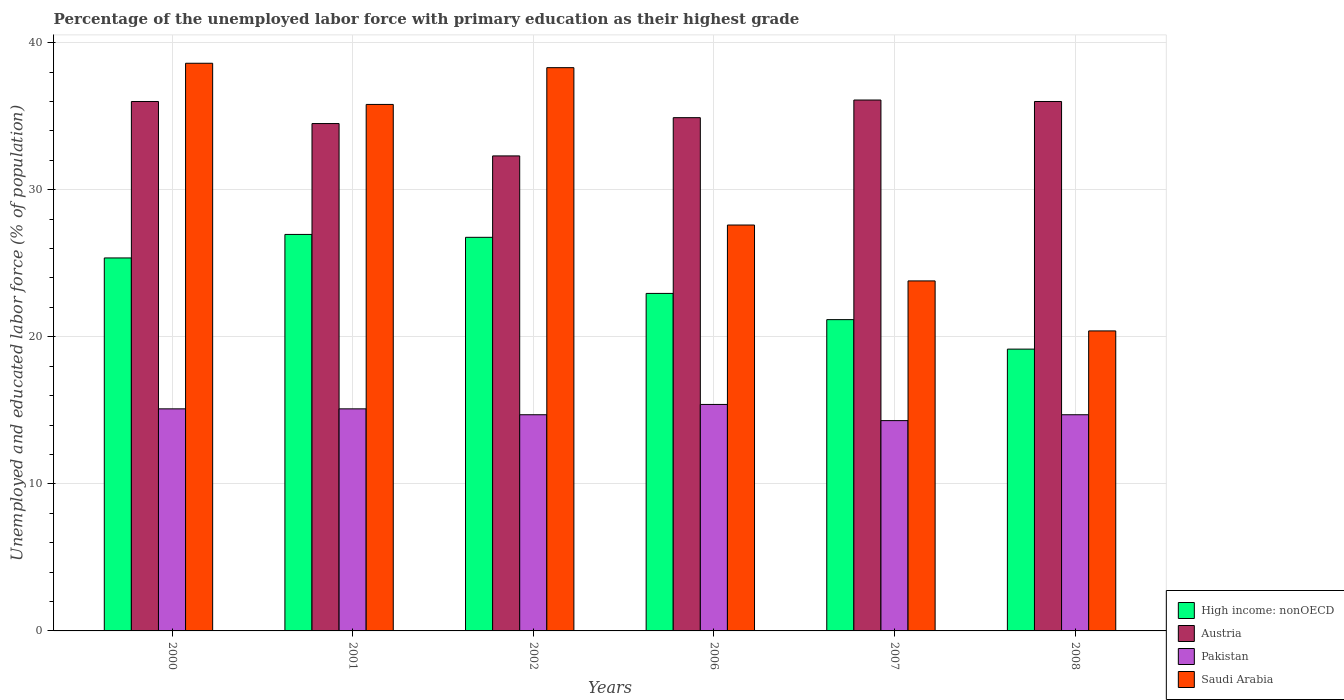How many different coloured bars are there?
Your answer should be very brief. 4. Are the number of bars per tick equal to the number of legend labels?
Provide a short and direct response. Yes. How many bars are there on the 1st tick from the left?
Your answer should be compact. 4. In how many cases, is the number of bars for a given year not equal to the number of legend labels?
Your answer should be compact. 0. What is the percentage of the unemployed labor force with primary education in Pakistan in 2008?
Offer a very short reply. 14.7. Across all years, what is the maximum percentage of the unemployed labor force with primary education in High income: nonOECD?
Provide a succinct answer. 26.96. Across all years, what is the minimum percentage of the unemployed labor force with primary education in Saudi Arabia?
Your response must be concise. 20.4. What is the total percentage of the unemployed labor force with primary education in High income: nonOECD in the graph?
Keep it short and to the point. 142.37. What is the difference between the percentage of the unemployed labor force with primary education in Austria in 2000 and that in 2007?
Make the answer very short. -0.1. What is the difference between the percentage of the unemployed labor force with primary education in Saudi Arabia in 2008 and the percentage of the unemployed labor force with primary education in Austria in 2006?
Make the answer very short. -14.5. What is the average percentage of the unemployed labor force with primary education in Pakistan per year?
Make the answer very short. 14.88. In the year 2002, what is the difference between the percentage of the unemployed labor force with primary education in Austria and percentage of the unemployed labor force with primary education in Pakistan?
Your answer should be compact. 17.6. What is the ratio of the percentage of the unemployed labor force with primary education in Austria in 2002 to that in 2008?
Your answer should be compact. 0.9. Is the difference between the percentage of the unemployed labor force with primary education in Austria in 2000 and 2002 greater than the difference between the percentage of the unemployed labor force with primary education in Pakistan in 2000 and 2002?
Offer a very short reply. Yes. What is the difference between the highest and the second highest percentage of the unemployed labor force with primary education in High income: nonOECD?
Your answer should be very brief. 0.2. What is the difference between the highest and the lowest percentage of the unemployed labor force with primary education in Pakistan?
Give a very brief answer. 1.1. In how many years, is the percentage of the unemployed labor force with primary education in Austria greater than the average percentage of the unemployed labor force with primary education in Austria taken over all years?
Keep it short and to the point. 3. Is the sum of the percentage of the unemployed labor force with primary education in Austria in 2001 and 2002 greater than the maximum percentage of the unemployed labor force with primary education in High income: nonOECD across all years?
Give a very brief answer. Yes. What does the 4th bar from the right in 2008 represents?
Give a very brief answer. High income: nonOECD. Is it the case that in every year, the sum of the percentage of the unemployed labor force with primary education in Saudi Arabia and percentage of the unemployed labor force with primary education in Pakistan is greater than the percentage of the unemployed labor force with primary education in Austria?
Give a very brief answer. No. Are all the bars in the graph horizontal?
Provide a succinct answer. No. How many years are there in the graph?
Your answer should be very brief. 6. Does the graph contain any zero values?
Provide a short and direct response. No. How many legend labels are there?
Provide a short and direct response. 4. What is the title of the graph?
Provide a short and direct response. Percentage of the unemployed labor force with primary education as their highest grade. What is the label or title of the Y-axis?
Give a very brief answer. Unemployed and educated labor force (% of population). What is the Unemployed and educated labor force (% of population) in High income: nonOECD in 2000?
Your response must be concise. 25.36. What is the Unemployed and educated labor force (% of population) of Pakistan in 2000?
Your answer should be compact. 15.1. What is the Unemployed and educated labor force (% of population) in Saudi Arabia in 2000?
Your answer should be very brief. 38.6. What is the Unemployed and educated labor force (% of population) in High income: nonOECD in 2001?
Keep it short and to the point. 26.96. What is the Unemployed and educated labor force (% of population) in Austria in 2001?
Your answer should be compact. 34.5. What is the Unemployed and educated labor force (% of population) of Pakistan in 2001?
Make the answer very short. 15.1. What is the Unemployed and educated labor force (% of population) in Saudi Arabia in 2001?
Offer a terse response. 35.8. What is the Unemployed and educated labor force (% of population) of High income: nonOECD in 2002?
Ensure brevity in your answer.  26.76. What is the Unemployed and educated labor force (% of population) of Austria in 2002?
Ensure brevity in your answer.  32.3. What is the Unemployed and educated labor force (% of population) of Pakistan in 2002?
Your answer should be compact. 14.7. What is the Unemployed and educated labor force (% of population) in Saudi Arabia in 2002?
Give a very brief answer. 38.3. What is the Unemployed and educated labor force (% of population) in High income: nonOECD in 2006?
Give a very brief answer. 22.95. What is the Unemployed and educated labor force (% of population) of Austria in 2006?
Ensure brevity in your answer.  34.9. What is the Unemployed and educated labor force (% of population) in Pakistan in 2006?
Offer a terse response. 15.4. What is the Unemployed and educated labor force (% of population) in Saudi Arabia in 2006?
Your response must be concise. 27.6. What is the Unemployed and educated labor force (% of population) of High income: nonOECD in 2007?
Your response must be concise. 21.17. What is the Unemployed and educated labor force (% of population) in Austria in 2007?
Ensure brevity in your answer.  36.1. What is the Unemployed and educated labor force (% of population) of Pakistan in 2007?
Keep it short and to the point. 14.3. What is the Unemployed and educated labor force (% of population) of Saudi Arabia in 2007?
Give a very brief answer. 23.8. What is the Unemployed and educated labor force (% of population) in High income: nonOECD in 2008?
Your answer should be very brief. 19.16. What is the Unemployed and educated labor force (% of population) in Pakistan in 2008?
Offer a very short reply. 14.7. What is the Unemployed and educated labor force (% of population) in Saudi Arabia in 2008?
Your response must be concise. 20.4. Across all years, what is the maximum Unemployed and educated labor force (% of population) of High income: nonOECD?
Keep it short and to the point. 26.96. Across all years, what is the maximum Unemployed and educated labor force (% of population) of Austria?
Make the answer very short. 36.1. Across all years, what is the maximum Unemployed and educated labor force (% of population) in Pakistan?
Provide a short and direct response. 15.4. Across all years, what is the maximum Unemployed and educated labor force (% of population) of Saudi Arabia?
Provide a succinct answer. 38.6. Across all years, what is the minimum Unemployed and educated labor force (% of population) of High income: nonOECD?
Keep it short and to the point. 19.16. Across all years, what is the minimum Unemployed and educated labor force (% of population) of Austria?
Offer a terse response. 32.3. Across all years, what is the minimum Unemployed and educated labor force (% of population) of Pakistan?
Give a very brief answer. 14.3. Across all years, what is the minimum Unemployed and educated labor force (% of population) of Saudi Arabia?
Offer a very short reply. 20.4. What is the total Unemployed and educated labor force (% of population) in High income: nonOECD in the graph?
Give a very brief answer. 142.37. What is the total Unemployed and educated labor force (% of population) in Austria in the graph?
Provide a succinct answer. 209.8. What is the total Unemployed and educated labor force (% of population) in Pakistan in the graph?
Your answer should be compact. 89.3. What is the total Unemployed and educated labor force (% of population) of Saudi Arabia in the graph?
Give a very brief answer. 184.5. What is the difference between the Unemployed and educated labor force (% of population) in High income: nonOECD in 2000 and that in 2001?
Keep it short and to the point. -1.6. What is the difference between the Unemployed and educated labor force (% of population) of Austria in 2000 and that in 2001?
Your response must be concise. 1.5. What is the difference between the Unemployed and educated labor force (% of population) of Pakistan in 2000 and that in 2001?
Provide a succinct answer. 0. What is the difference between the Unemployed and educated labor force (% of population) of Saudi Arabia in 2000 and that in 2001?
Your answer should be compact. 2.8. What is the difference between the Unemployed and educated labor force (% of population) of High income: nonOECD in 2000 and that in 2002?
Your answer should be compact. -1.4. What is the difference between the Unemployed and educated labor force (% of population) of Pakistan in 2000 and that in 2002?
Give a very brief answer. 0.4. What is the difference between the Unemployed and educated labor force (% of population) in Saudi Arabia in 2000 and that in 2002?
Provide a short and direct response. 0.3. What is the difference between the Unemployed and educated labor force (% of population) in High income: nonOECD in 2000 and that in 2006?
Your answer should be very brief. 2.41. What is the difference between the Unemployed and educated labor force (% of population) of Saudi Arabia in 2000 and that in 2006?
Make the answer very short. 11. What is the difference between the Unemployed and educated labor force (% of population) in High income: nonOECD in 2000 and that in 2007?
Offer a terse response. 4.19. What is the difference between the Unemployed and educated labor force (% of population) of Austria in 2000 and that in 2007?
Offer a very short reply. -0.1. What is the difference between the Unemployed and educated labor force (% of population) in Pakistan in 2000 and that in 2007?
Keep it short and to the point. 0.8. What is the difference between the Unemployed and educated labor force (% of population) of Saudi Arabia in 2000 and that in 2007?
Your response must be concise. 14.8. What is the difference between the Unemployed and educated labor force (% of population) in High income: nonOECD in 2000 and that in 2008?
Keep it short and to the point. 6.2. What is the difference between the Unemployed and educated labor force (% of population) in Pakistan in 2000 and that in 2008?
Provide a short and direct response. 0.4. What is the difference between the Unemployed and educated labor force (% of population) of High income: nonOECD in 2001 and that in 2002?
Provide a succinct answer. 0.2. What is the difference between the Unemployed and educated labor force (% of population) in Austria in 2001 and that in 2002?
Ensure brevity in your answer.  2.2. What is the difference between the Unemployed and educated labor force (% of population) in Saudi Arabia in 2001 and that in 2002?
Your response must be concise. -2.5. What is the difference between the Unemployed and educated labor force (% of population) in High income: nonOECD in 2001 and that in 2006?
Provide a succinct answer. 4.01. What is the difference between the Unemployed and educated labor force (% of population) in Austria in 2001 and that in 2006?
Your answer should be compact. -0.4. What is the difference between the Unemployed and educated labor force (% of population) of Pakistan in 2001 and that in 2006?
Ensure brevity in your answer.  -0.3. What is the difference between the Unemployed and educated labor force (% of population) in High income: nonOECD in 2001 and that in 2007?
Provide a succinct answer. 5.79. What is the difference between the Unemployed and educated labor force (% of population) of Austria in 2001 and that in 2007?
Ensure brevity in your answer.  -1.6. What is the difference between the Unemployed and educated labor force (% of population) of Saudi Arabia in 2001 and that in 2007?
Offer a terse response. 12. What is the difference between the Unemployed and educated labor force (% of population) in High income: nonOECD in 2001 and that in 2008?
Your answer should be compact. 7.8. What is the difference between the Unemployed and educated labor force (% of population) in Austria in 2001 and that in 2008?
Ensure brevity in your answer.  -1.5. What is the difference between the Unemployed and educated labor force (% of population) of Pakistan in 2001 and that in 2008?
Make the answer very short. 0.4. What is the difference between the Unemployed and educated labor force (% of population) in Saudi Arabia in 2001 and that in 2008?
Offer a terse response. 15.4. What is the difference between the Unemployed and educated labor force (% of population) of High income: nonOECD in 2002 and that in 2006?
Give a very brief answer. 3.81. What is the difference between the Unemployed and educated labor force (% of population) in Austria in 2002 and that in 2006?
Provide a short and direct response. -2.6. What is the difference between the Unemployed and educated labor force (% of population) of Pakistan in 2002 and that in 2006?
Your answer should be very brief. -0.7. What is the difference between the Unemployed and educated labor force (% of population) in Saudi Arabia in 2002 and that in 2006?
Provide a short and direct response. 10.7. What is the difference between the Unemployed and educated labor force (% of population) in High income: nonOECD in 2002 and that in 2007?
Keep it short and to the point. 5.6. What is the difference between the Unemployed and educated labor force (% of population) of Austria in 2002 and that in 2007?
Your answer should be compact. -3.8. What is the difference between the Unemployed and educated labor force (% of population) in Pakistan in 2002 and that in 2007?
Provide a short and direct response. 0.4. What is the difference between the Unemployed and educated labor force (% of population) of Saudi Arabia in 2002 and that in 2007?
Provide a short and direct response. 14.5. What is the difference between the Unemployed and educated labor force (% of population) in High income: nonOECD in 2002 and that in 2008?
Provide a short and direct response. 7.6. What is the difference between the Unemployed and educated labor force (% of population) in Austria in 2002 and that in 2008?
Keep it short and to the point. -3.7. What is the difference between the Unemployed and educated labor force (% of population) of Pakistan in 2002 and that in 2008?
Give a very brief answer. 0. What is the difference between the Unemployed and educated labor force (% of population) of Saudi Arabia in 2002 and that in 2008?
Make the answer very short. 17.9. What is the difference between the Unemployed and educated labor force (% of population) in High income: nonOECD in 2006 and that in 2007?
Your response must be concise. 1.78. What is the difference between the Unemployed and educated labor force (% of population) in High income: nonOECD in 2006 and that in 2008?
Offer a very short reply. 3.79. What is the difference between the Unemployed and educated labor force (% of population) in Austria in 2006 and that in 2008?
Keep it short and to the point. -1.1. What is the difference between the Unemployed and educated labor force (% of population) in High income: nonOECD in 2007 and that in 2008?
Your answer should be very brief. 2.01. What is the difference between the Unemployed and educated labor force (% of population) of Pakistan in 2007 and that in 2008?
Provide a short and direct response. -0.4. What is the difference between the Unemployed and educated labor force (% of population) of Saudi Arabia in 2007 and that in 2008?
Make the answer very short. 3.4. What is the difference between the Unemployed and educated labor force (% of population) of High income: nonOECD in 2000 and the Unemployed and educated labor force (% of population) of Austria in 2001?
Make the answer very short. -9.14. What is the difference between the Unemployed and educated labor force (% of population) of High income: nonOECD in 2000 and the Unemployed and educated labor force (% of population) of Pakistan in 2001?
Provide a succinct answer. 10.26. What is the difference between the Unemployed and educated labor force (% of population) in High income: nonOECD in 2000 and the Unemployed and educated labor force (% of population) in Saudi Arabia in 2001?
Offer a terse response. -10.44. What is the difference between the Unemployed and educated labor force (% of population) of Austria in 2000 and the Unemployed and educated labor force (% of population) of Pakistan in 2001?
Ensure brevity in your answer.  20.9. What is the difference between the Unemployed and educated labor force (% of population) in Austria in 2000 and the Unemployed and educated labor force (% of population) in Saudi Arabia in 2001?
Offer a terse response. 0.2. What is the difference between the Unemployed and educated labor force (% of population) in Pakistan in 2000 and the Unemployed and educated labor force (% of population) in Saudi Arabia in 2001?
Your answer should be very brief. -20.7. What is the difference between the Unemployed and educated labor force (% of population) in High income: nonOECD in 2000 and the Unemployed and educated labor force (% of population) in Austria in 2002?
Your answer should be compact. -6.94. What is the difference between the Unemployed and educated labor force (% of population) in High income: nonOECD in 2000 and the Unemployed and educated labor force (% of population) in Pakistan in 2002?
Keep it short and to the point. 10.66. What is the difference between the Unemployed and educated labor force (% of population) in High income: nonOECD in 2000 and the Unemployed and educated labor force (% of population) in Saudi Arabia in 2002?
Keep it short and to the point. -12.94. What is the difference between the Unemployed and educated labor force (% of population) of Austria in 2000 and the Unemployed and educated labor force (% of population) of Pakistan in 2002?
Make the answer very short. 21.3. What is the difference between the Unemployed and educated labor force (% of population) in Pakistan in 2000 and the Unemployed and educated labor force (% of population) in Saudi Arabia in 2002?
Offer a very short reply. -23.2. What is the difference between the Unemployed and educated labor force (% of population) in High income: nonOECD in 2000 and the Unemployed and educated labor force (% of population) in Austria in 2006?
Your answer should be very brief. -9.54. What is the difference between the Unemployed and educated labor force (% of population) in High income: nonOECD in 2000 and the Unemployed and educated labor force (% of population) in Pakistan in 2006?
Provide a succinct answer. 9.96. What is the difference between the Unemployed and educated labor force (% of population) in High income: nonOECD in 2000 and the Unemployed and educated labor force (% of population) in Saudi Arabia in 2006?
Your response must be concise. -2.24. What is the difference between the Unemployed and educated labor force (% of population) of Austria in 2000 and the Unemployed and educated labor force (% of population) of Pakistan in 2006?
Provide a short and direct response. 20.6. What is the difference between the Unemployed and educated labor force (% of population) in Austria in 2000 and the Unemployed and educated labor force (% of population) in Saudi Arabia in 2006?
Your response must be concise. 8.4. What is the difference between the Unemployed and educated labor force (% of population) in High income: nonOECD in 2000 and the Unemployed and educated labor force (% of population) in Austria in 2007?
Make the answer very short. -10.74. What is the difference between the Unemployed and educated labor force (% of population) of High income: nonOECD in 2000 and the Unemployed and educated labor force (% of population) of Pakistan in 2007?
Your answer should be compact. 11.06. What is the difference between the Unemployed and educated labor force (% of population) of High income: nonOECD in 2000 and the Unemployed and educated labor force (% of population) of Saudi Arabia in 2007?
Offer a terse response. 1.56. What is the difference between the Unemployed and educated labor force (% of population) in Austria in 2000 and the Unemployed and educated labor force (% of population) in Pakistan in 2007?
Your answer should be compact. 21.7. What is the difference between the Unemployed and educated labor force (% of population) in Austria in 2000 and the Unemployed and educated labor force (% of population) in Saudi Arabia in 2007?
Your answer should be very brief. 12.2. What is the difference between the Unemployed and educated labor force (% of population) in Pakistan in 2000 and the Unemployed and educated labor force (% of population) in Saudi Arabia in 2007?
Provide a short and direct response. -8.7. What is the difference between the Unemployed and educated labor force (% of population) of High income: nonOECD in 2000 and the Unemployed and educated labor force (% of population) of Austria in 2008?
Provide a short and direct response. -10.64. What is the difference between the Unemployed and educated labor force (% of population) of High income: nonOECD in 2000 and the Unemployed and educated labor force (% of population) of Pakistan in 2008?
Ensure brevity in your answer.  10.66. What is the difference between the Unemployed and educated labor force (% of population) of High income: nonOECD in 2000 and the Unemployed and educated labor force (% of population) of Saudi Arabia in 2008?
Your response must be concise. 4.96. What is the difference between the Unemployed and educated labor force (% of population) of Austria in 2000 and the Unemployed and educated labor force (% of population) of Pakistan in 2008?
Your answer should be compact. 21.3. What is the difference between the Unemployed and educated labor force (% of population) in Pakistan in 2000 and the Unemployed and educated labor force (% of population) in Saudi Arabia in 2008?
Offer a very short reply. -5.3. What is the difference between the Unemployed and educated labor force (% of population) in High income: nonOECD in 2001 and the Unemployed and educated labor force (% of population) in Austria in 2002?
Your answer should be compact. -5.34. What is the difference between the Unemployed and educated labor force (% of population) in High income: nonOECD in 2001 and the Unemployed and educated labor force (% of population) in Pakistan in 2002?
Keep it short and to the point. 12.26. What is the difference between the Unemployed and educated labor force (% of population) of High income: nonOECD in 2001 and the Unemployed and educated labor force (% of population) of Saudi Arabia in 2002?
Make the answer very short. -11.34. What is the difference between the Unemployed and educated labor force (% of population) in Austria in 2001 and the Unemployed and educated labor force (% of population) in Pakistan in 2002?
Offer a very short reply. 19.8. What is the difference between the Unemployed and educated labor force (% of population) in Austria in 2001 and the Unemployed and educated labor force (% of population) in Saudi Arabia in 2002?
Make the answer very short. -3.8. What is the difference between the Unemployed and educated labor force (% of population) of Pakistan in 2001 and the Unemployed and educated labor force (% of population) of Saudi Arabia in 2002?
Your response must be concise. -23.2. What is the difference between the Unemployed and educated labor force (% of population) in High income: nonOECD in 2001 and the Unemployed and educated labor force (% of population) in Austria in 2006?
Your response must be concise. -7.94. What is the difference between the Unemployed and educated labor force (% of population) in High income: nonOECD in 2001 and the Unemployed and educated labor force (% of population) in Pakistan in 2006?
Offer a terse response. 11.56. What is the difference between the Unemployed and educated labor force (% of population) in High income: nonOECD in 2001 and the Unemployed and educated labor force (% of population) in Saudi Arabia in 2006?
Your answer should be compact. -0.64. What is the difference between the Unemployed and educated labor force (% of population) in Pakistan in 2001 and the Unemployed and educated labor force (% of population) in Saudi Arabia in 2006?
Offer a very short reply. -12.5. What is the difference between the Unemployed and educated labor force (% of population) of High income: nonOECD in 2001 and the Unemployed and educated labor force (% of population) of Austria in 2007?
Give a very brief answer. -9.14. What is the difference between the Unemployed and educated labor force (% of population) in High income: nonOECD in 2001 and the Unemployed and educated labor force (% of population) in Pakistan in 2007?
Offer a very short reply. 12.66. What is the difference between the Unemployed and educated labor force (% of population) of High income: nonOECD in 2001 and the Unemployed and educated labor force (% of population) of Saudi Arabia in 2007?
Ensure brevity in your answer.  3.16. What is the difference between the Unemployed and educated labor force (% of population) of Austria in 2001 and the Unemployed and educated labor force (% of population) of Pakistan in 2007?
Offer a very short reply. 20.2. What is the difference between the Unemployed and educated labor force (% of population) of High income: nonOECD in 2001 and the Unemployed and educated labor force (% of population) of Austria in 2008?
Your response must be concise. -9.04. What is the difference between the Unemployed and educated labor force (% of population) of High income: nonOECD in 2001 and the Unemployed and educated labor force (% of population) of Pakistan in 2008?
Make the answer very short. 12.26. What is the difference between the Unemployed and educated labor force (% of population) of High income: nonOECD in 2001 and the Unemployed and educated labor force (% of population) of Saudi Arabia in 2008?
Ensure brevity in your answer.  6.56. What is the difference between the Unemployed and educated labor force (% of population) of Austria in 2001 and the Unemployed and educated labor force (% of population) of Pakistan in 2008?
Your answer should be compact. 19.8. What is the difference between the Unemployed and educated labor force (% of population) of Austria in 2001 and the Unemployed and educated labor force (% of population) of Saudi Arabia in 2008?
Offer a very short reply. 14.1. What is the difference between the Unemployed and educated labor force (% of population) of High income: nonOECD in 2002 and the Unemployed and educated labor force (% of population) of Austria in 2006?
Your answer should be compact. -8.14. What is the difference between the Unemployed and educated labor force (% of population) of High income: nonOECD in 2002 and the Unemployed and educated labor force (% of population) of Pakistan in 2006?
Your answer should be very brief. 11.36. What is the difference between the Unemployed and educated labor force (% of population) in High income: nonOECD in 2002 and the Unemployed and educated labor force (% of population) in Saudi Arabia in 2006?
Provide a short and direct response. -0.84. What is the difference between the Unemployed and educated labor force (% of population) of Austria in 2002 and the Unemployed and educated labor force (% of population) of Pakistan in 2006?
Offer a terse response. 16.9. What is the difference between the Unemployed and educated labor force (% of population) in Pakistan in 2002 and the Unemployed and educated labor force (% of population) in Saudi Arabia in 2006?
Your answer should be compact. -12.9. What is the difference between the Unemployed and educated labor force (% of population) of High income: nonOECD in 2002 and the Unemployed and educated labor force (% of population) of Austria in 2007?
Offer a very short reply. -9.34. What is the difference between the Unemployed and educated labor force (% of population) in High income: nonOECD in 2002 and the Unemployed and educated labor force (% of population) in Pakistan in 2007?
Make the answer very short. 12.46. What is the difference between the Unemployed and educated labor force (% of population) in High income: nonOECD in 2002 and the Unemployed and educated labor force (% of population) in Saudi Arabia in 2007?
Make the answer very short. 2.96. What is the difference between the Unemployed and educated labor force (% of population) in Austria in 2002 and the Unemployed and educated labor force (% of population) in Saudi Arabia in 2007?
Your answer should be very brief. 8.5. What is the difference between the Unemployed and educated labor force (% of population) in Pakistan in 2002 and the Unemployed and educated labor force (% of population) in Saudi Arabia in 2007?
Keep it short and to the point. -9.1. What is the difference between the Unemployed and educated labor force (% of population) of High income: nonOECD in 2002 and the Unemployed and educated labor force (% of population) of Austria in 2008?
Your answer should be compact. -9.24. What is the difference between the Unemployed and educated labor force (% of population) in High income: nonOECD in 2002 and the Unemployed and educated labor force (% of population) in Pakistan in 2008?
Ensure brevity in your answer.  12.06. What is the difference between the Unemployed and educated labor force (% of population) in High income: nonOECD in 2002 and the Unemployed and educated labor force (% of population) in Saudi Arabia in 2008?
Offer a terse response. 6.36. What is the difference between the Unemployed and educated labor force (% of population) in Austria in 2002 and the Unemployed and educated labor force (% of population) in Saudi Arabia in 2008?
Keep it short and to the point. 11.9. What is the difference between the Unemployed and educated labor force (% of population) of Pakistan in 2002 and the Unemployed and educated labor force (% of population) of Saudi Arabia in 2008?
Your answer should be compact. -5.7. What is the difference between the Unemployed and educated labor force (% of population) of High income: nonOECD in 2006 and the Unemployed and educated labor force (% of population) of Austria in 2007?
Provide a succinct answer. -13.15. What is the difference between the Unemployed and educated labor force (% of population) of High income: nonOECD in 2006 and the Unemployed and educated labor force (% of population) of Pakistan in 2007?
Offer a very short reply. 8.65. What is the difference between the Unemployed and educated labor force (% of population) in High income: nonOECD in 2006 and the Unemployed and educated labor force (% of population) in Saudi Arabia in 2007?
Provide a succinct answer. -0.85. What is the difference between the Unemployed and educated labor force (% of population) in Austria in 2006 and the Unemployed and educated labor force (% of population) in Pakistan in 2007?
Ensure brevity in your answer.  20.6. What is the difference between the Unemployed and educated labor force (% of population) in Austria in 2006 and the Unemployed and educated labor force (% of population) in Saudi Arabia in 2007?
Make the answer very short. 11.1. What is the difference between the Unemployed and educated labor force (% of population) in High income: nonOECD in 2006 and the Unemployed and educated labor force (% of population) in Austria in 2008?
Offer a terse response. -13.05. What is the difference between the Unemployed and educated labor force (% of population) in High income: nonOECD in 2006 and the Unemployed and educated labor force (% of population) in Pakistan in 2008?
Give a very brief answer. 8.25. What is the difference between the Unemployed and educated labor force (% of population) in High income: nonOECD in 2006 and the Unemployed and educated labor force (% of population) in Saudi Arabia in 2008?
Make the answer very short. 2.55. What is the difference between the Unemployed and educated labor force (% of population) of Austria in 2006 and the Unemployed and educated labor force (% of population) of Pakistan in 2008?
Your answer should be compact. 20.2. What is the difference between the Unemployed and educated labor force (% of population) of Austria in 2006 and the Unemployed and educated labor force (% of population) of Saudi Arabia in 2008?
Offer a terse response. 14.5. What is the difference between the Unemployed and educated labor force (% of population) in Pakistan in 2006 and the Unemployed and educated labor force (% of population) in Saudi Arabia in 2008?
Make the answer very short. -5. What is the difference between the Unemployed and educated labor force (% of population) in High income: nonOECD in 2007 and the Unemployed and educated labor force (% of population) in Austria in 2008?
Offer a terse response. -14.83. What is the difference between the Unemployed and educated labor force (% of population) of High income: nonOECD in 2007 and the Unemployed and educated labor force (% of population) of Pakistan in 2008?
Your answer should be compact. 6.47. What is the difference between the Unemployed and educated labor force (% of population) of High income: nonOECD in 2007 and the Unemployed and educated labor force (% of population) of Saudi Arabia in 2008?
Your answer should be compact. 0.77. What is the difference between the Unemployed and educated labor force (% of population) of Austria in 2007 and the Unemployed and educated labor force (% of population) of Pakistan in 2008?
Offer a very short reply. 21.4. What is the difference between the Unemployed and educated labor force (% of population) of Austria in 2007 and the Unemployed and educated labor force (% of population) of Saudi Arabia in 2008?
Give a very brief answer. 15.7. What is the average Unemployed and educated labor force (% of population) of High income: nonOECD per year?
Ensure brevity in your answer.  23.73. What is the average Unemployed and educated labor force (% of population) in Austria per year?
Provide a short and direct response. 34.97. What is the average Unemployed and educated labor force (% of population) in Pakistan per year?
Provide a succinct answer. 14.88. What is the average Unemployed and educated labor force (% of population) of Saudi Arabia per year?
Provide a short and direct response. 30.75. In the year 2000, what is the difference between the Unemployed and educated labor force (% of population) of High income: nonOECD and Unemployed and educated labor force (% of population) of Austria?
Your response must be concise. -10.64. In the year 2000, what is the difference between the Unemployed and educated labor force (% of population) in High income: nonOECD and Unemployed and educated labor force (% of population) in Pakistan?
Your answer should be compact. 10.26. In the year 2000, what is the difference between the Unemployed and educated labor force (% of population) of High income: nonOECD and Unemployed and educated labor force (% of population) of Saudi Arabia?
Your response must be concise. -13.24. In the year 2000, what is the difference between the Unemployed and educated labor force (% of population) of Austria and Unemployed and educated labor force (% of population) of Pakistan?
Make the answer very short. 20.9. In the year 2000, what is the difference between the Unemployed and educated labor force (% of population) of Pakistan and Unemployed and educated labor force (% of population) of Saudi Arabia?
Your response must be concise. -23.5. In the year 2001, what is the difference between the Unemployed and educated labor force (% of population) in High income: nonOECD and Unemployed and educated labor force (% of population) in Austria?
Your answer should be compact. -7.54. In the year 2001, what is the difference between the Unemployed and educated labor force (% of population) in High income: nonOECD and Unemployed and educated labor force (% of population) in Pakistan?
Ensure brevity in your answer.  11.86. In the year 2001, what is the difference between the Unemployed and educated labor force (% of population) of High income: nonOECD and Unemployed and educated labor force (% of population) of Saudi Arabia?
Keep it short and to the point. -8.84. In the year 2001, what is the difference between the Unemployed and educated labor force (% of population) in Austria and Unemployed and educated labor force (% of population) in Pakistan?
Offer a very short reply. 19.4. In the year 2001, what is the difference between the Unemployed and educated labor force (% of population) in Pakistan and Unemployed and educated labor force (% of population) in Saudi Arabia?
Offer a very short reply. -20.7. In the year 2002, what is the difference between the Unemployed and educated labor force (% of population) of High income: nonOECD and Unemployed and educated labor force (% of population) of Austria?
Provide a succinct answer. -5.54. In the year 2002, what is the difference between the Unemployed and educated labor force (% of population) in High income: nonOECD and Unemployed and educated labor force (% of population) in Pakistan?
Offer a terse response. 12.06. In the year 2002, what is the difference between the Unemployed and educated labor force (% of population) in High income: nonOECD and Unemployed and educated labor force (% of population) in Saudi Arabia?
Give a very brief answer. -11.54. In the year 2002, what is the difference between the Unemployed and educated labor force (% of population) of Austria and Unemployed and educated labor force (% of population) of Pakistan?
Provide a succinct answer. 17.6. In the year 2002, what is the difference between the Unemployed and educated labor force (% of population) of Austria and Unemployed and educated labor force (% of population) of Saudi Arabia?
Give a very brief answer. -6. In the year 2002, what is the difference between the Unemployed and educated labor force (% of population) in Pakistan and Unemployed and educated labor force (% of population) in Saudi Arabia?
Provide a succinct answer. -23.6. In the year 2006, what is the difference between the Unemployed and educated labor force (% of population) of High income: nonOECD and Unemployed and educated labor force (% of population) of Austria?
Provide a succinct answer. -11.95. In the year 2006, what is the difference between the Unemployed and educated labor force (% of population) in High income: nonOECD and Unemployed and educated labor force (% of population) in Pakistan?
Make the answer very short. 7.55. In the year 2006, what is the difference between the Unemployed and educated labor force (% of population) of High income: nonOECD and Unemployed and educated labor force (% of population) of Saudi Arabia?
Ensure brevity in your answer.  -4.65. In the year 2006, what is the difference between the Unemployed and educated labor force (% of population) of Austria and Unemployed and educated labor force (% of population) of Pakistan?
Ensure brevity in your answer.  19.5. In the year 2006, what is the difference between the Unemployed and educated labor force (% of population) in Austria and Unemployed and educated labor force (% of population) in Saudi Arabia?
Keep it short and to the point. 7.3. In the year 2007, what is the difference between the Unemployed and educated labor force (% of population) in High income: nonOECD and Unemployed and educated labor force (% of population) in Austria?
Offer a terse response. -14.93. In the year 2007, what is the difference between the Unemployed and educated labor force (% of population) of High income: nonOECD and Unemployed and educated labor force (% of population) of Pakistan?
Your answer should be very brief. 6.87. In the year 2007, what is the difference between the Unemployed and educated labor force (% of population) of High income: nonOECD and Unemployed and educated labor force (% of population) of Saudi Arabia?
Ensure brevity in your answer.  -2.63. In the year 2007, what is the difference between the Unemployed and educated labor force (% of population) of Austria and Unemployed and educated labor force (% of population) of Pakistan?
Provide a succinct answer. 21.8. In the year 2007, what is the difference between the Unemployed and educated labor force (% of population) in Pakistan and Unemployed and educated labor force (% of population) in Saudi Arabia?
Make the answer very short. -9.5. In the year 2008, what is the difference between the Unemployed and educated labor force (% of population) in High income: nonOECD and Unemployed and educated labor force (% of population) in Austria?
Your answer should be very brief. -16.84. In the year 2008, what is the difference between the Unemployed and educated labor force (% of population) in High income: nonOECD and Unemployed and educated labor force (% of population) in Pakistan?
Make the answer very short. 4.46. In the year 2008, what is the difference between the Unemployed and educated labor force (% of population) in High income: nonOECD and Unemployed and educated labor force (% of population) in Saudi Arabia?
Offer a terse response. -1.24. In the year 2008, what is the difference between the Unemployed and educated labor force (% of population) in Austria and Unemployed and educated labor force (% of population) in Pakistan?
Make the answer very short. 21.3. What is the ratio of the Unemployed and educated labor force (% of population) in High income: nonOECD in 2000 to that in 2001?
Offer a very short reply. 0.94. What is the ratio of the Unemployed and educated labor force (% of population) of Austria in 2000 to that in 2001?
Make the answer very short. 1.04. What is the ratio of the Unemployed and educated labor force (% of population) in Pakistan in 2000 to that in 2001?
Provide a short and direct response. 1. What is the ratio of the Unemployed and educated labor force (% of population) of Saudi Arabia in 2000 to that in 2001?
Your response must be concise. 1.08. What is the ratio of the Unemployed and educated labor force (% of population) of High income: nonOECD in 2000 to that in 2002?
Ensure brevity in your answer.  0.95. What is the ratio of the Unemployed and educated labor force (% of population) in Austria in 2000 to that in 2002?
Your answer should be very brief. 1.11. What is the ratio of the Unemployed and educated labor force (% of population) in Pakistan in 2000 to that in 2002?
Ensure brevity in your answer.  1.03. What is the ratio of the Unemployed and educated labor force (% of population) in High income: nonOECD in 2000 to that in 2006?
Keep it short and to the point. 1.11. What is the ratio of the Unemployed and educated labor force (% of population) in Austria in 2000 to that in 2006?
Ensure brevity in your answer.  1.03. What is the ratio of the Unemployed and educated labor force (% of population) of Pakistan in 2000 to that in 2006?
Your answer should be very brief. 0.98. What is the ratio of the Unemployed and educated labor force (% of population) of Saudi Arabia in 2000 to that in 2006?
Provide a short and direct response. 1.4. What is the ratio of the Unemployed and educated labor force (% of population) of High income: nonOECD in 2000 to that in 2007?
Give a very brief answer. 1.2. What is the ratio of the Unemployed and educated labor force (% of population) of Pakistan in 2000 to that in 2007?
Your answer should be compact. 1.06. What is the ratio of the Unemployed and educated labor force (% of population) in Saudi Arabia in 2000 to that in 2007?
Make the answer very short. 1.62. What is the ratio of the Unemployed and educated labor force (% of population) of High income: nonOECD in 2000 to that in 2008?
Your response must be concise. 1.32. What is the ratio of the Unemployed and educated labor force (% of population) in Pakistan in 2000 to that in 2008?
Make the answer very short. 1.03. What is the ratio of the Unemployed and educated labor force (% of population) of Saudi Arabia in 2000 to that in 2008?
Provide a short and direct response. 1.89. What is the ratio of the Unemployed and educated labor force (% of population) in High income: nonOECD in 2001 to that in 2002?
Give a very brief answer. 1.01. What is the ratio of the Unemployed and educated labor force (% of population) of Austria in 2001 to that in 2002?
Your answer should be compact. 1.07. What is the ratio of the Unemployed and educated labor force (% of population) in Pakistan in 2001 to that in 2002?
Keep it short and to the point. 1.03. What is the ratio of the Unemployed and educated labor force (% of population) in Saudi Arabia in 2001 to that in 2002?
Make the answer very short. 0.93. What is the ratio of the Unemployed and educated labor force (% of population) of High income: nonOECD in 2001 to that in 2006?
Your answer should be very brief. 1.17. What is the ratio of the Unemployed and educated labor force (% of population) of Pakistan in 2001 to that in 2006?
Offer a terse response. 0.98. What is the ratio of the Unemployed and educated labor force (% of population) of Saudi Arabia in 2001 to that in 2006?
Provide a succinct answer. 1.3. What is the ratio of the Unemployed and educated labor force (% of population) in High income: nonOECD in 2001 to that in 2007?
Your answer should be very brief. 1.27. What is the ratio of the Unemployed and educated labor force (% of population) of Austria in 2001 to that in 2007?
Your response must be concise. 0.96. What is the ratio of the Unemployed and educated labor force (% of population) in Pakistan in 2001 to that in 2007?
Provide a succinct answer. 1.06. What is the ratio of the Unemployed and educated labor force (% of population) of Saudi Arabia in 2001 to that in 2007?
Provide a short and direct response. 1.5. What is the ratio of the Unemployed and educated labor force (% of population) of High income: nonOECD in 2001 to that in 2008?
Your response must be concise. 1.41. What is the ratio of the Unemployed and educated labor force (% of population) in Pakistan in 2001 to that in 2008?
Your answer should be compact. 1.03. What is the ratio of the Unemployed and educated labor force (% of population) of Saudi Arabia in 2001 to that in 2008?
Offer a terse response. 1.75. What is the ratio of the Unemployed and educated labor force (% of population) in High income: nonOECD in 2002 to that in 2006?
Make the answer very short. 1.17. What is the ratio of the Unemployed and educated labor force (% of population) in Austria in 2002 to that in 2006?
Offer a terse response. 0.93. What is the ratio of the Unemployed and educated labor force (% of population) of Pakistan in 2002 to that in 2006?
Your answer should be very brief. 0.95. What is the ratio of the Unemployed and educated labor force (% of population) of Saudi Arabia in 2002 to that in 2006?
Ensure brevity in your answer.  1.39. What is the ratio of the Unemployed and educated labor force (% of population) of High income: nonOECD in 2002 to that in 2007?
Your answer should be very brief. 1.26. What is the ratio of the Unemployed and educated labor force (% of population) of Austria in 2002 to that in 2007?
Provide a succinct answer. 0.89. What is the ratio of the Unemployed and educated labor force (% of population) in Pakistan in 2002 to that in 2007?
Give a very brief answer. 1.03. What is the ratio of the Unemployed and educated labor force (% of population) in Saudi Arabia in 2002 to that in 2007?
Keep it short and to the point. 1.61. What is the ratio of the Unemployed and educated labor force (% of population) of High income: nonOECD in 2002 to that in 2008?
Make the answer very short. 1.4. What is the ratio of the Unemployed and educated labor force (% of population) of Austria in 2002 to that in 2008?
Offer a very short reply. 0.9. What is the ratio of the Unemployed and educated labor force (% of population) in Saudi Arabia in 2002 to that in 2008?
Give a very brief answer. 1.88. What is the ratio of the Unemployed and educated labor force (% of population) in High income: nonOECD in 2006 to that in 2007?
Your answer should be compact. 1.08. What is the ratio of the Unemployed and educated labor force (% of population) of Austria in 2006 to that in 2007?
Give a very brief answer. 0.97. What is the ratio of the Unemployed and educated labor force (% of population) in Pakistan in 2006 to that in 2007?
Your answer should be very brief. 1.08. What is the ratio of the Unemployed and educated labor force (% of population) in Saudi Arabia in 2006 to that in 2007?
Make the answer very short. 1.16. What is the ratio of the Unemployed and educated labor force (% of population) in High income: nonOECD in 2006 to that in 2008?
Your answer should be very brief. 1.2. What is the ratio of the Unemployed and educated labor force (% of population) in Austria in 2006 to that in 2008?
Provide a short and direct response. 0.97. What is the ratio of the Unemployed and educated labor force (% of population) of Pakistan in 2006 to that in 2008?
Your answer should be very brief. 1.05. What is the ratio of the Unemployed and educated labor force (% of population) of Saudi Arabia in 2006 to that in 2008?
Offer a very short reply. 1.35. What is the ratio of the Unemployed and educated labor force (% of population) of High income: nonOECD in 2007 to that in 2008?
Keep it short and to the point. 1.1. What is the ratio of the Unemployed and educated labor force (% of population) in Austria in 2007 to that in 2008?
Provide a short and direct response. 1. What is the ratio of the Unemployed and educated labor force (% of population) in Pakistan in 2007 to that in 2008?
Offer a terse response. 0.97. What is the difference between the highest and the second highest Unemployed and educated labor force (% of population) of High income: nonOECD?
Keep it short and to the point. 0.2. What is the difference between the highest and the second highest Unemployed and educated labor force (% of population) in Pakistan?
Your answer should be compact. 0.3. What is the difference between the highest and the lowest Unemployed and educated labor force (% of population) in High income: nonOECD?
Provide a short and direct response. 7.8. What is the difference between the highest and the lowest Unemployed and educated labor force (% of population) in Austria?
Your answer should be compact. 3.8. 